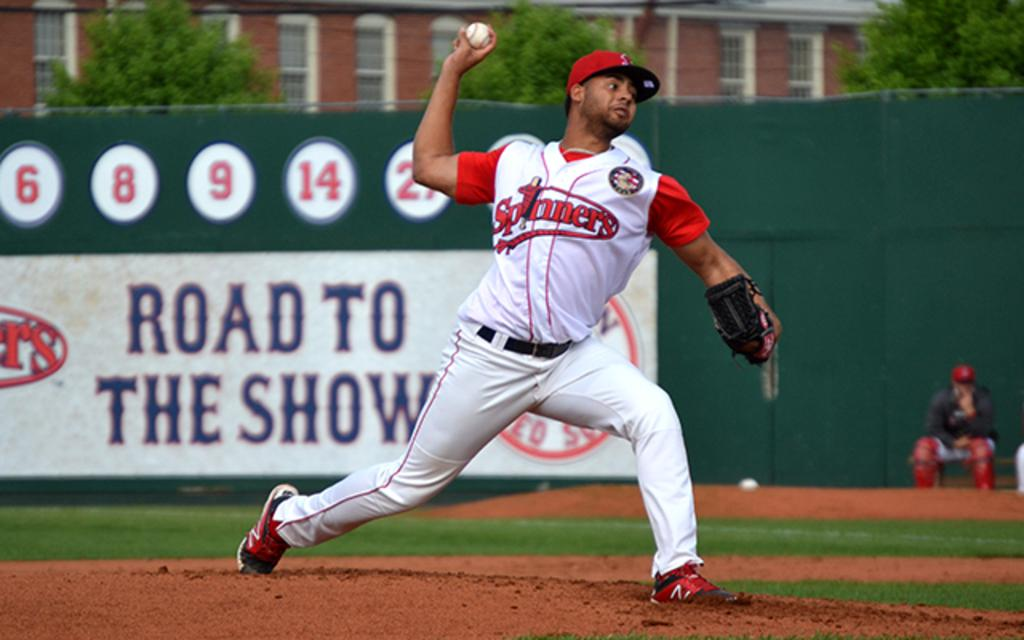Provide a one-sentence caption for the provided image. A man wears a Spinners baseball uniform on a baseball diamond. 